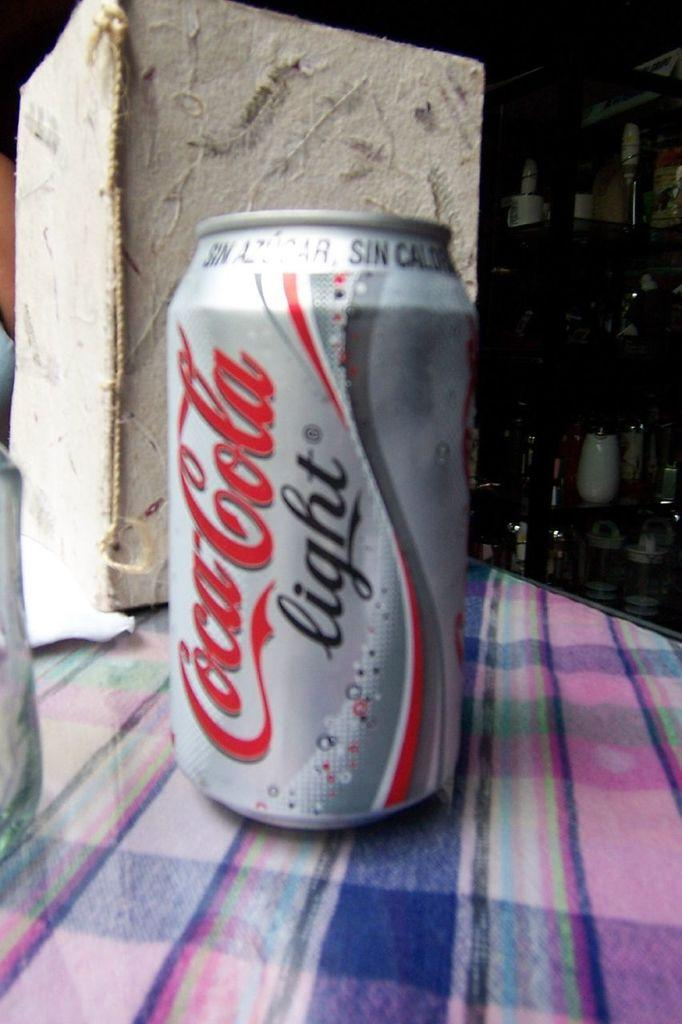<image>
Describe the image concisely. A silver, white and red can of coca cola light sitting on a plaid table cloth. 